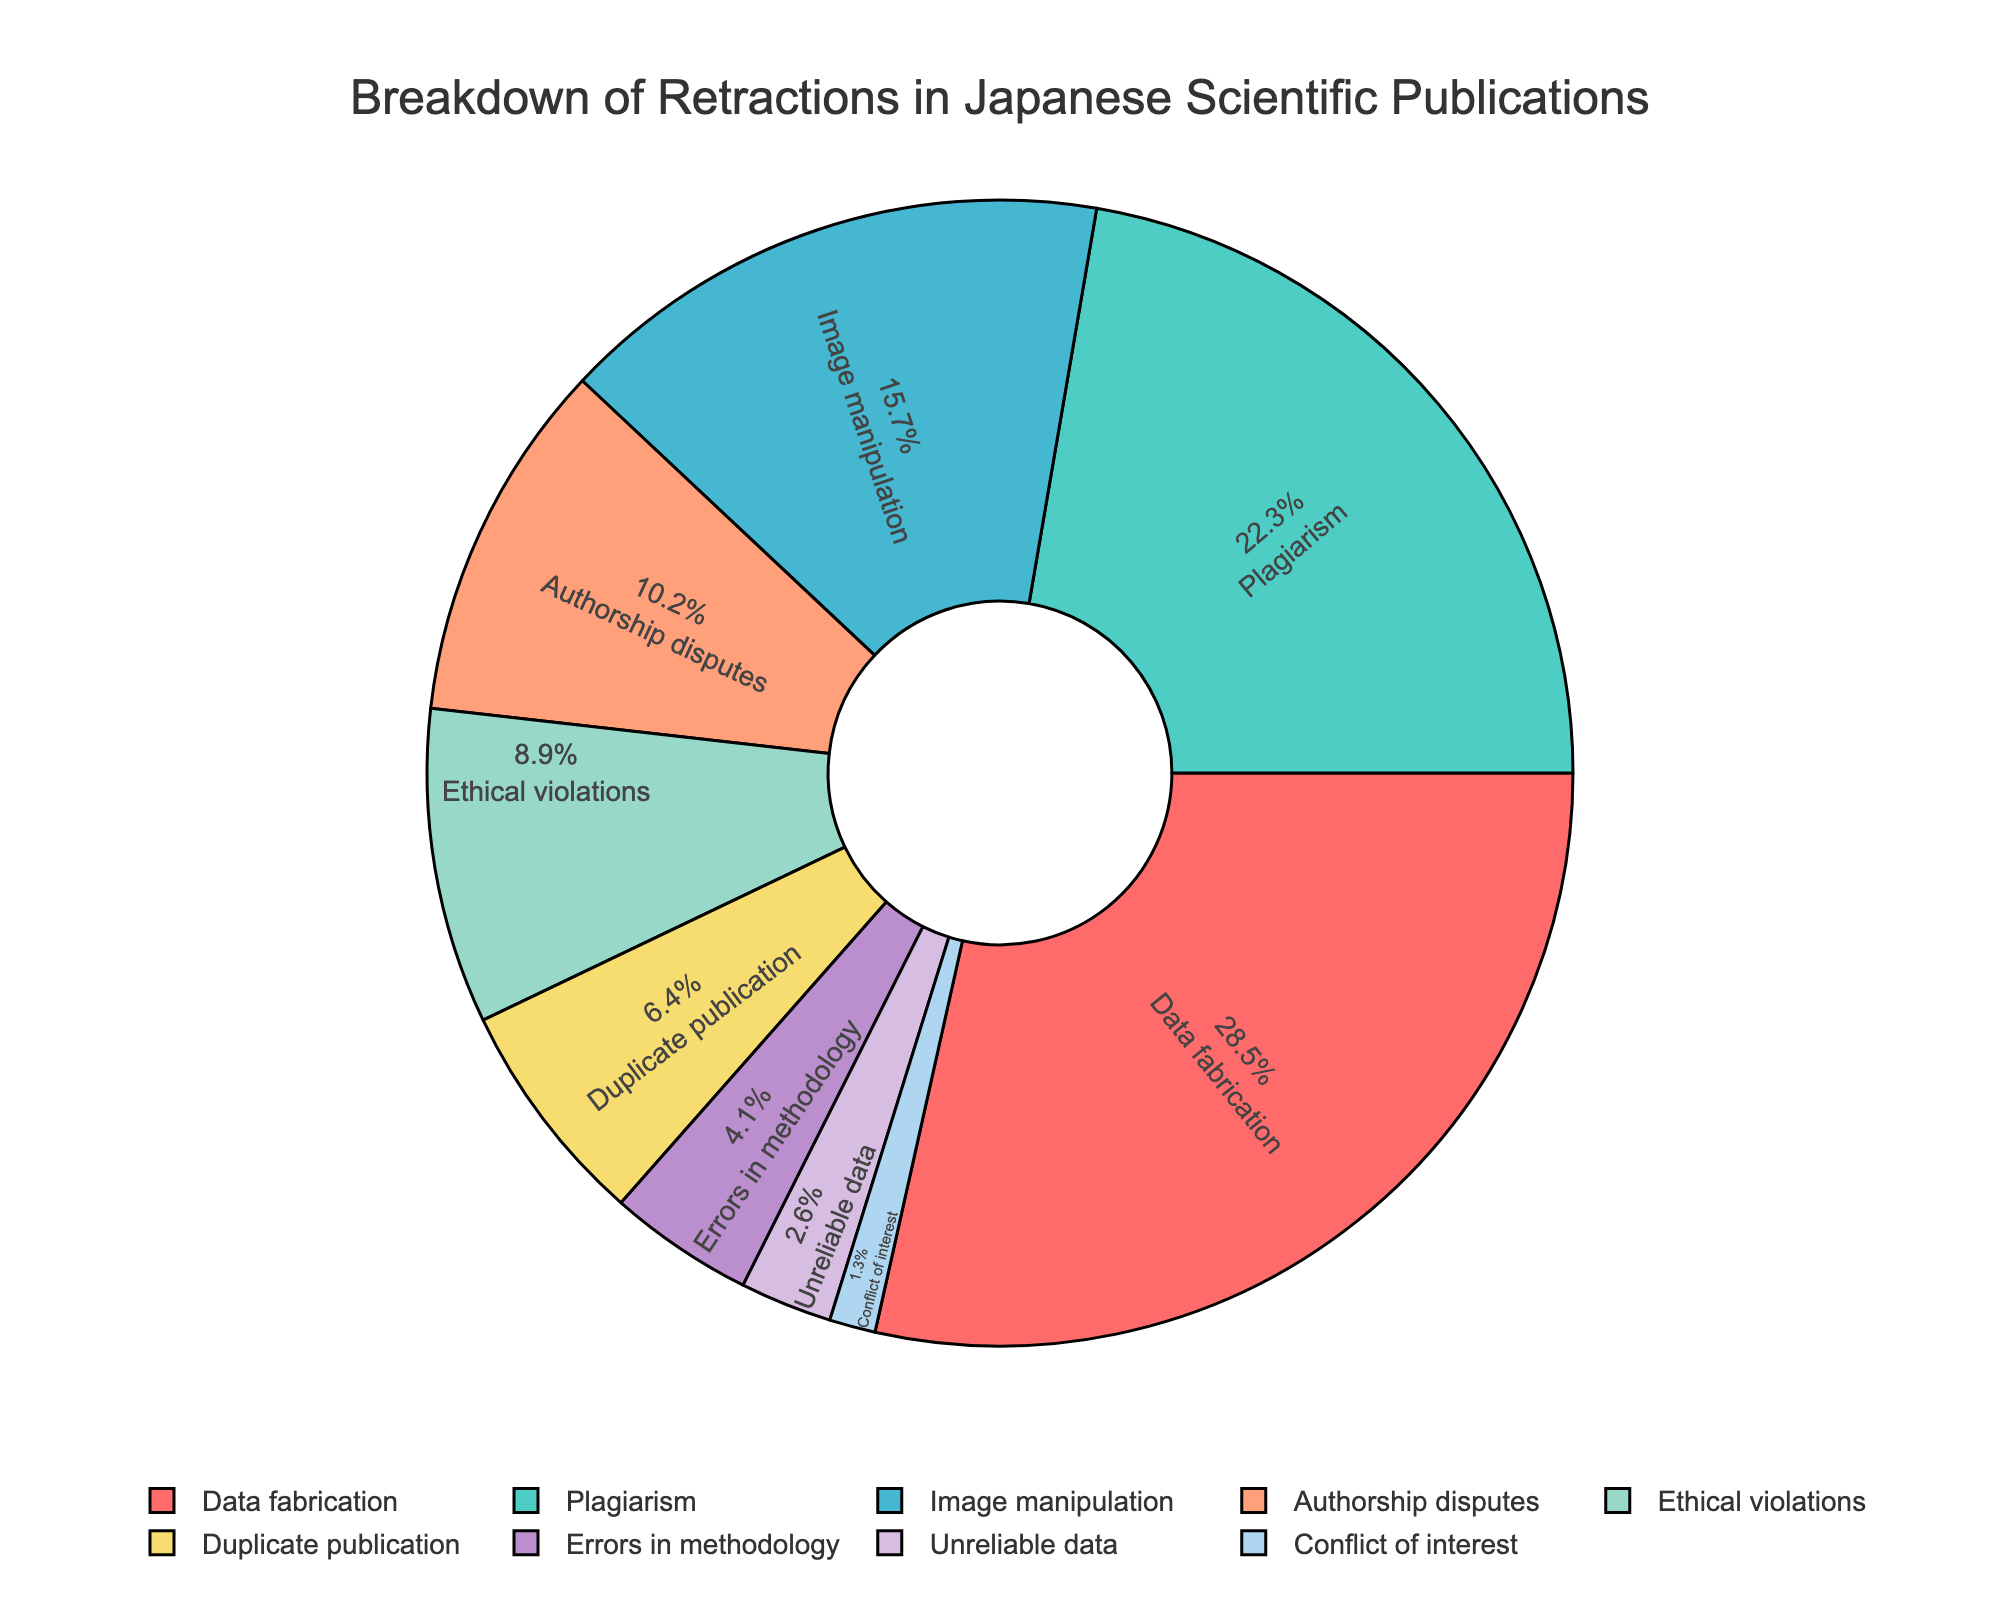What is the most common reason for retractions in Japanese scientific publications? The figure shows the breakdown of retractions, and the largest segment corresponds to 'Data fabrication'. By comparing the percentages, we see that 'Data fabrication' has the highest one at 28.5%.
Answer: Data fabrication Which two reasons combined account for more than 50% of retractions? Adding the percentages for each reason, we see that the two highest ones, 'Data fabrication' (28.5%) and 'Plagiarism' (22.3%), together account for 50.8%.
Answer: Data fabrication and Plagiarism Which reason has the smallest percentage of retractions? By checking the percentages in the figure, the smallest segment corresponds to 'Conflict of interest' with 1.3%.
Answer: Conflict of interest How does the percentage of 'Ethical violations' compare to 'Authorship disputes'? 'Ethical violations' have a percentage of 8.9%, while 'Authorship disputes' have 10.2%. Comparing these, 'Authorship disputes' is higher than 'Ethical violations'.
Answer: Authorship disputes is higher What percentage of retractions are due to issues related to 'methodology and data' (Errors in methodology + Unreliable data)? Adding the percentages of 'Errors in methodology' (4.1%) and 'Unreliable data' (2.6%), we get 4.1% + 2.6% = 6.7%.
Answer: 6.7% Is the percentage of 'Duplicate publication' higher than that of 'Errors in methodology'? 'Duplicate publication' has a percentage of 6.4%, while 'Errors in methodology' have 4.1%. Thus, 'Duplicate publication' is higher.
Answer: Yes Which reason has a percentage closest to 10%? Among the given reasons, 'Authorship disputes' has a percentage of 10.2%, which is closest to 10%.
Answer: Authorship disputes What is the total percentage for reasons related to 'integrity violations' (Data fabrication + Plagiarism + Image manipulation)? Summing the percentages for 'Data fabrication' (28.5%), 'Plagiarism' (22.3%), and 'Image manipulation' (15.7%), we get 28.5% + 22.3% + 15.7% = 66.5%.
Answer: 66.5% Based on the color coding, what color represents 'Image manipulation'? The segment for 'Image manipulation' is displayed in a perceptible color which is between the segment for 'Plagiarism' and 'Authorship disputes'. It is visually shown as a shade similar to light blue.
Answer: Light blue 